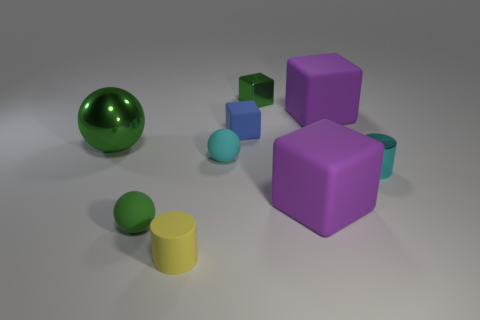What is the shape of the metallic thing that is the same color as the metal sphere?
Your answer should be very brief. Cube. What material is the thing that is to the right of the purple thing behind the tiny rubber block?
Give a very brief answer. Metal. What number of objects are small cyan objects or big objects that are behind the cyan matte thing?
Provide a succinct answer. 4. What size is the yellow cylinder that is the same material as the blue object?
Keep it short and to the point. Small. Are there more rubber objects that are to the right of the yellow cylinder than things?
Provide a short and direct response. No. How big is the ball that is both to the left of the yellow matte cylinder and in front of the big green metallic sphere?
Offer a very short reply. Small. What is the material of the other green thing that is the same shape as the large green metallic object?
Give a very brief answer. Rubber. Do the rubber cylinder left of the cyan rubber object and the cyan metal cylinder have the same size?
Offer a very short reply. Yes. What is the color of the tiny thing that is both right of the green rubber object and in front of the cyan metallic cylinder?
Offer a terse response. Yellow. There is a block in front of the big green sphere; what number of objects are behind it?
Your response must be concise. 6. 